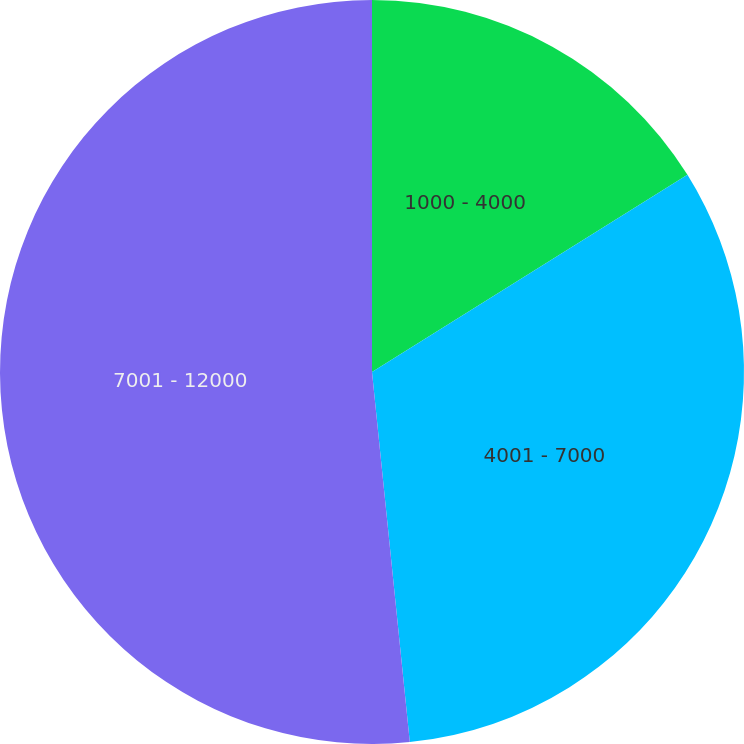<chart> <loc_0><loc_0><loc_500><loc_500><pie_chart><fcel>1000 - 4000<fcel>4001 - 7000<fcel>7001 - 12000<nl><fcel>16.11%<fcel>32.27%<fcel>51.62%<nl></chart> 